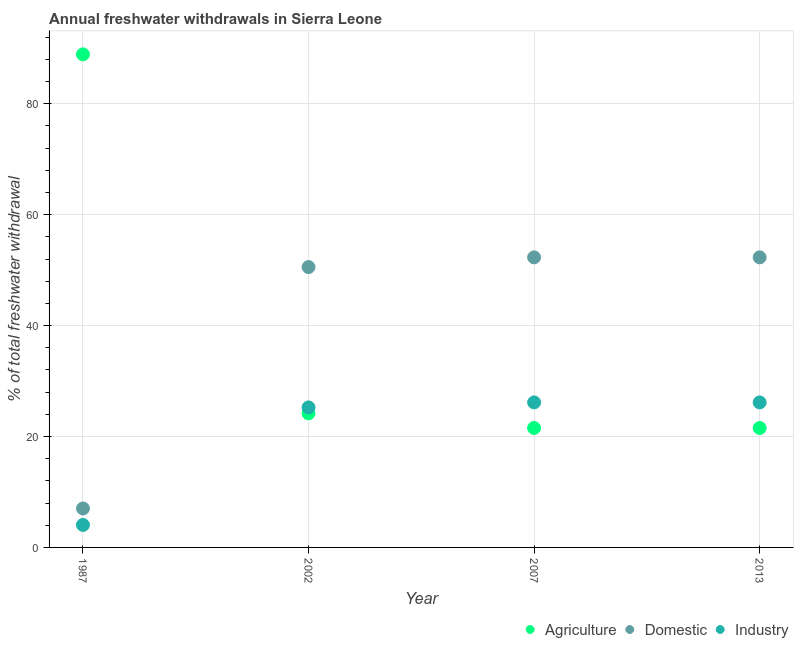What is the percentage of freshwater withdrawal for domestic purposes in 2002?
Keep it short and to the point. 50.56. Across all years, what is the maximum percentage of freshwater withdrawal for industry?
Your answer should be compact. 26.15. Across all years, what is the minimum percentage of freshwater withdrawal for domestic purposes?
Provide a succinct answer. 7.03. In which year was the percentage of freshwater withdrawal for industry maximum?
Your response must be concise. 2007. In which year was the percentage of freshwater withdrawal for agriculture minimum?
Provide a short and direct response. 2007. What is the total percentage of freshwater withdrawal for industry in the graph?
Give a very brief answer. 81.6. What is the difference between the percentage of freshwater withdrawal for agriculture in 1987 and that in 2013?
Provide a short and direct response. 67.38. What is the difference between the percentage of freshwater withdrawal for domestic purposes in 1987 and the percentage of freshwater withdrawal for industry in 2002?
Keep it short and to the point. -18.22. What is the average percentage of freshwater withdrawal for industry per year?
Offer a very short reply. 20.4. In the year 1987, what is the difference between the percentage of freshwater withdrawal for agriculture and percentage of freshwater withdrawal for domestic purposes?
Make the answer very short. 81.89. What is the ratio of the percentage of freshwater withdrawal for domestic purposes in 1987 to that in 2007?
Provide a succinct answer. 0.13. What is the difference between the highest and the lowest percentage of freshwater withdrawal for domestic purposes?
Keep it short and to the point. 45.28. In how many years, is the percentage of freshwater withdrawal for industry greater than the average percentage of freshwater withdrawal for industry taken over all years?
Offer a terse response. 3. Is the sum of the percentage of freshwater withdrawal for domestic purposes in 1987 and 2002 greater than the maximum percentage of freshwater withdrawal for industry across all years?
Offer a very short reply. Yes. Does the percentage of freshwater withdrawal for domestic purposes monotonically increase over the years?
Give a very brief answer. No. Is the percentage of freshwater withdrawal for industry strictly greater than the percentage of freshwater withdrawal for domestic purposes over the years?
Provide a succinct answer. No. What is the difference between two consecutive major ticks on the Y-axis?
Your answer should be very brief. 20. Are the values on the major ticks of Y-axis written in scientific E-notation?
Provide a succinct answer. No. Does the graph contain any zero values?
Give a very brief answer. No. What is the title of the graph?
Provide a short and direct response. Annual freshwater withdrawals in Sierra Leone. Does "Transport equipments" appear as one of the legend labels in the graph?
Ensure brevity in your answer.  No. What is the label or title of the X-axis?
Offer a terse response. Year. What is the label or title of the Y-axis?
Provide a short and direct response. % of total freshwater withdrawal. What is the % of total freshwater withdrawal in Agriculture in 1987?
Provide a short and direct response. 88.92. What is the % of total freshwater withdrawal in Domestic in 1987?
Your response must be concise. 7.03. What is the % of total freshwater withdrawal in Industry in 1987?
Offer a very short reply. 4.05. What is the % of total freshwater withdrawal in Agriculture in 2002?
Your answer should be very brief. 24.19. What is the % of total freshwater withdrawal of Domestic in 2002?
Ensure brevity in your answer.  50.56. What is the % of total freshwater withdrawal of Industry in 2002?
Provide a short and direct response. 25.25. What is the % of total freshwater withdrawal in Agriculture in 2007?
Ensure brevity in your answer.  21.54. What is the % of total freshwater withdrawal in Domestic in 2007?
Your answer should be very brief. 52.31. What is the % of total freshwater withdrawal in Industry in 2007?
Your response must be concise. 26.15. What is the % of total freshwater withdrawal of Agriculture in 2013?
Ensure brevity in your answer.  21.54. What is the % of total freshwater withdrawal in Domestic in 2013?
Offer a terse response. 52.31. What is the % of total freshwater withdrawal in Industry in 2013?
Provide a short and direct response. 26.15. Across all years, what is the maximum % of total freshwater withdrawal in Agriculture?
Ensure brevity in your answer.  88.92. Across all years, what is the maximum % of total freshwater withdrawal of Domestic?
Provide a succinct answer. 52.31. Across all years, what is the maximum % of total freshwater withdrawal in Industry?
Ensure brevity in your answer.  26.15. Across all years, what is the minimum % of total freshwater withdrawal of Agriculture?
Your answer should be compact. 21.54. Across all years, what is the minimum % of total freshwater withdrawal in Domestic?
Ensure brevity in your answer.  7.03. Across all years, what is the minimum % of total freshwater withdrawal in Industry?
Offer a terse response. 4.05. What is the total % of total freshwater withdrawal of Agriculture in the graph?
Keep it short and to the point. 156.19. What is the total % of total freshwater withdrawal of Domestic in the graph?
Offer a terse response. 162.21. What is the total % of total freshwater withdrawal in Industry in the graph?
Provide a short and direct response. 81.6. What is the difference between the % of total freshwater withdrawal of Agriculture in 1987 and that in 2002?
Give a very brief answer. 64.73. What is the difference between the % of total freshwater withdrawal in Domestic in 1987 and that in 2002?
Provide a succinct answer. -43.53. What is the difference between the % of total freshwater withdrawal of Industry in 1987 and that in 2002?
Your answer should be compact. -21.2. What is the difference between the % of total freshwater withdrawal in Agriculture in 1987 and that in 2007?
Your answer should be very brief. 67.38. What is the difference between the % of total freshwater withdrawal of Domestic in 1987 and that in 2007?
Offer a terse response. -45.28. What is the difference between the % of total freshwater withdrawal in Industry in 1987 and that in 2007?
Provide a short and direct response. -22.1. What is the difference between the % of total freshwater withdrawal in Agriculture in 1987 and that in 2013?
Your answer should be very brief. 67.38. What is the difference between the % of total freshwater withdrawal of Domestic in 1987 and that in 2013?
Offer a very short reply. -45.28. What is the difference between the % of total freshwater withdrawal of Industry in 1987 and that in 2013?
Your response must be concise. -22.1. What is the difference between the % of total freshwater withdrawal in Agriculture in 2002 and that in 2007?
Offer a terse response. 2.65. What is the difference between the % of total freshwater withdrawal of Domestic in 2002 and that in 2007?
Offer a very short reply. -1.75. What is the difference between the % of total freshwater withdrawal of Agriculture in 2002 and that in 2013?
Your answer should be very brief. 2.65. What is the difference between the % of total freshwater withdrawal in Domestic in 2002 and that in 2013?
Your response must be concise. -1.75. What is the difference between the % of total freshwater withdrawal in Industry in 2002 and that in 2013?
Ensure brevity in your answer.  -0.9. What is the difference between the % of total freshwater withdrawal of Agriculture in 2007 and that in 2013?
Your response must be concise. 0. What is the difference between the % of total freshwater withdrawal in Industry in 2007 and that in 2013?
Your answer should be very brief. 0. What is the difference between the % of total freshwater withdrawal of Agriculture in 1987 and the % of total freshwater withdrawal of Domestic in 2002?
Give a very brief answer. 38.36. What is the difference between the % of total freshwater withdrawal in Agriculture in 1987 and the % of total freshwater withdrawal in Industry in 2002?
Offer a terse response. 63.67. What is the difference between the % of total freshwater withdrawal of Domestic in 1987 and the % of total freshwater withdrawal of Industry in 2002?
Provide a short and direct response. -18.22. What is the difference between the % of total freshwater withdrawal in Agriculture in 1987 and the % of total freshwater withdrawal in Domestic in 2007?
Your answer should be compact. 36.61. What is the difference between the % of total freshwater withdrawal of Agriculture in 1987 and the % of total freshwater withdrawal of Industry in 2007?
Keep it short and to the point. 62.77. What is the difference between the % of total freshwater withdrawal in Domestic in 1987 and the % of total freshwater withdrawal in Industry in 2007?
Give a very brief answer. -19.12. What is the difference between the % of total freshwater withdrawal of Agriculture in 1987 and the % of total freshwater withdrawal of Domestic in 2013?
Your answer should be compact. 36.61. What is the difference between the % of total freshwater withdrawal of Agriculture in 1987 and the % of total freshwater withdrawal of Industry in 2013?
Give a very brief answer. 62.77. What is the difference between the % of total freshwater withdrawal in Domestic in 1987 and the % of total freshwater withdrawal in Industry in 2013?
Provide a succinct answer. -19.12. What is the difference between the % of total freshwater withdrawal in Agriculture in 2002 and the % of total freshwater withdrawal in Domestic in 2007?
Your answer should be compact. -28.12. What is the difference between the % of total freshwater withdrawal in Agriculture in 2002 and the % of total freshwater withdrawal in Industry in 2007?
Make the answer very short. -1.96. What is the difference between the % of total freshwater withdrawal of Domestic in 2002 and the % of total freshwater withdrawal of Industry in 2007?
Ensure brevity in your answer.  24.41. What is the difference between the % of total freshwater withdrawal of Agriculture in 2002 and the % of total freshwater withdrawal of Domestic in 2013?
Offer a terse response. -28.12. What is the difference between the % of total freshwater withdrawal in Agriculture in 2002 and the % of total freshwater withdrawal in Industry in 2013?
Offer a very short reply. -1.96. What is the difference between the % of total freshwater withdrawal in Domestic in 2002 and the % of total freshwater withdrawal in Industry in 2013?
Ensure brevity in your answer.  24.41. What is the difference between the % of total freshwater withdrawal of Agriculture in 2007 and the % of total freshwater withdrawal of Domestic in 2013?
Your answer should be very brief. -30.77. What is the difference between the % of total freshwater withdrawal in Agriculture in 2007 and the % of total freshwater withdrawal in Industry in 2013?
Give a very brief answer. -4.61. What is the difference between the % of total freshwater withdrawal in Domestic in 2007 and the % of total freshwater withdrawal in Industry in 2013?
Keep it short and to the point. 26.16. What is the average % of total freshwater withdrawal of Agriculture per year?
Your answer should be compact. 39.05. What is the average % of total freshwater withdrawal of Domestic per year?
Your answer should be very brief. 40.55. What is the average % of total freshwater withdrawal of Industry per year?
Make the answer very short. 20.4. In the year 1987, what is the difference between the % of total freshwater withdrawal of Agriculture and % of total freshwater withdrawal of Domestic?
Make the answer very short. 81.89. In the year 1987, what is the difference between the % of total freshwater withdrawal in Agriculture and % of total freshwater withdrawal in Industry?
Make the answer very short. 84.87. In the year 1987, what is the difference between the % of total freshwater withdrawal in Domestic and % of total freshwater withdrawal in Industry?
Offer a very short reply. 2.97. In the year 2002, what is the difference between the % of total freshwater withdrawal of Agriculture and % of total freshwater withdrawal of Domestic?
Make the answer very short. -26.37. In the year 2002, what is the difference between the % of total freshwater withdrawal of Agriculture and % of total freshwater withdrawal of Industry?
Offer a terse response. -1.06. In the year 2002, what is the difference between the % of total freshwater withdrawal in Domestic and % of total freshwater withdrawal in Industry?
Give a very brief answer. 25.31. In the year 2007, what is the difference between the % of total freshwater withdrawal of Agriculture and % of total freshwater withdrawal of Domestic?
Provide a succinct answer. -30.77. In the year 2007, what is the difference between the % of total freshwater withdrawal in Agriculture and % of total freshwater withdrawal in Industry?
Your answer should be compact. -4.61. In the year 2007, what is the difference between the % of total freshwater withdrawal in Domestic and % of total freshwater withdrawal in Industry?
Your response must be concise. 26.16. In the year 2013, what is the difference between the % of total freshwater withdrawal of Agriculture and % of total freshwater withdrawal of Domestic?
Provide a succinct answer. -30.77. In the year 2013, what is the difference between the % of total freshwater withdrawal in Agriculture and % of total freshwater withdrawal in Industry?
Keep it short and to the point. -4.61. In the year 2013, what is the difference between the % of total freshwater withdrawal in Domestic and % of total freshwater withdrawal in Industry?
Offer a very short reply. 26.16. What is the ratio of the % of total freshwater withdrawal in Agriculture in 1987 to that in 2002?
Your answer should be compact. 3.68. What is the ratio of the % of total freshwater withdrawal of Domestic in 1987 to that in 2002?
Provide a succinct answer. 0.14. What is the ratio of the % of total freshwater withdrawal in Industry in 1987 to that in 2002?
Your response must be concise. 0.16. What is the ratio of the % of total freshwater withdrawal of Agriculture in 1987 to that in 2007?
Give a very brief answer. 4.13. What is the ratio of the % of total freshwater withdrawal in Domestic in 1987 to that in 2007?
Provide a succinct answer. 0.13. What is the ratio of the % of total freshwater withdrawal of Industry in 1987 to that in 2007?
Provide a succinct answer. 0.15. What is the ratio of the % of total freshwater withdrawal in Agriculture in 1987 to that in 2013?
Offer a very short reply. 4.13. What is the ratio of the % of total freshwater withdrawal in Domestic in 1987 to that in 2013?
Your answer should be very brief. 0.13. What is the ratio of the % of total freshwater withdrawal of Industry in 1987 to that in 2013?
Provide a succinct answer. 0.15. What is the ratio of the % of total freshwater withdrawal of Agriculture in 2002 to that in 2007?
Keep it short and to the point. 1.12. What is the ratio of the % of total freshwater withdrawal of Domestic in 2002 to that in 2007?
Ensure brevity in your answer.  0.97. What is the ratio of the % of total freshwater withdrawal in Industry in 2002 to that in 2007?
Provide a succinct answer. 0.97. What is the ratio of the % of total freshwater withdrawal in Agriculture in 2002 to that in 2013?
Ensure brevity in your answer.  1.12. What is the ratio of the % of total freshwater withdrawal of Domestic in 2002 to that in 2013?
Provide a short and direct response. 0.97. What is the ratio of the % of total freshwater withdrawal in Industry in 2002 to that in 2013?
Your answer should be very brief. 0.97. What is the ratio of the % of total freshwater withdrawal of Industry in 2007 to that in 2013?
Provide a short and direct response. 1. What is the difference between the highest and the second highest % of total freshwater withdrawal in Agriculture?
Your answer should be compact. 64.73. What is the difference between the highest and the lowest % of total freshwater withdrawal in Agriculture?
Provide a short and direct response. 67.38. What is the difference between the highest and the lowest % of total freshwater withdrawal in Domestic?
Make the answer very short. 45.28. What is the difference between the highest and the lowest % of total freshwater withdrawal in Industry?
Ensure brevity in your answer.  22.1. 